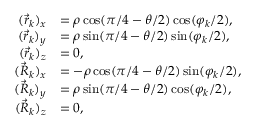Convert formula to latex. <formula><loc_0><loc_0><loc_500><loc_500>\begin{array} { r l } { ( \vec { r } _ { k } ) _ { x } } & { = \rho \cos ( \pi / 4 - \theta / 2 ) \cos ( \varphi _ { k } / 2 ) , } \\ { ( \vec { r } _ { k } ) _ { y } } & { = \rho \sin ( \pi / 4 - \theta / 2 ) \sin ( \varphi _ { k } / 2 ) , } \\ { ( \vec { r } _ { k } ) _ { z } } & { = 0 , } \\ { ( \vec { R } _ { k } ) _ { x } } & { = - \rho \cos ( \pi / 4 - \theta / 2 ) \sin ( \varphi _ { k } / 2 ) , } \\ { ( \vec { R } _ { k } ) _ { y } } & { = \rho \sin ( \pi / 4 - \theta / 2 ) \cos ( \varphi _ { k } / 2 ) , } \\ { ( \vec { R } _ { k } ) _ { z } } & { = 0 , } \end{array}</formula> 